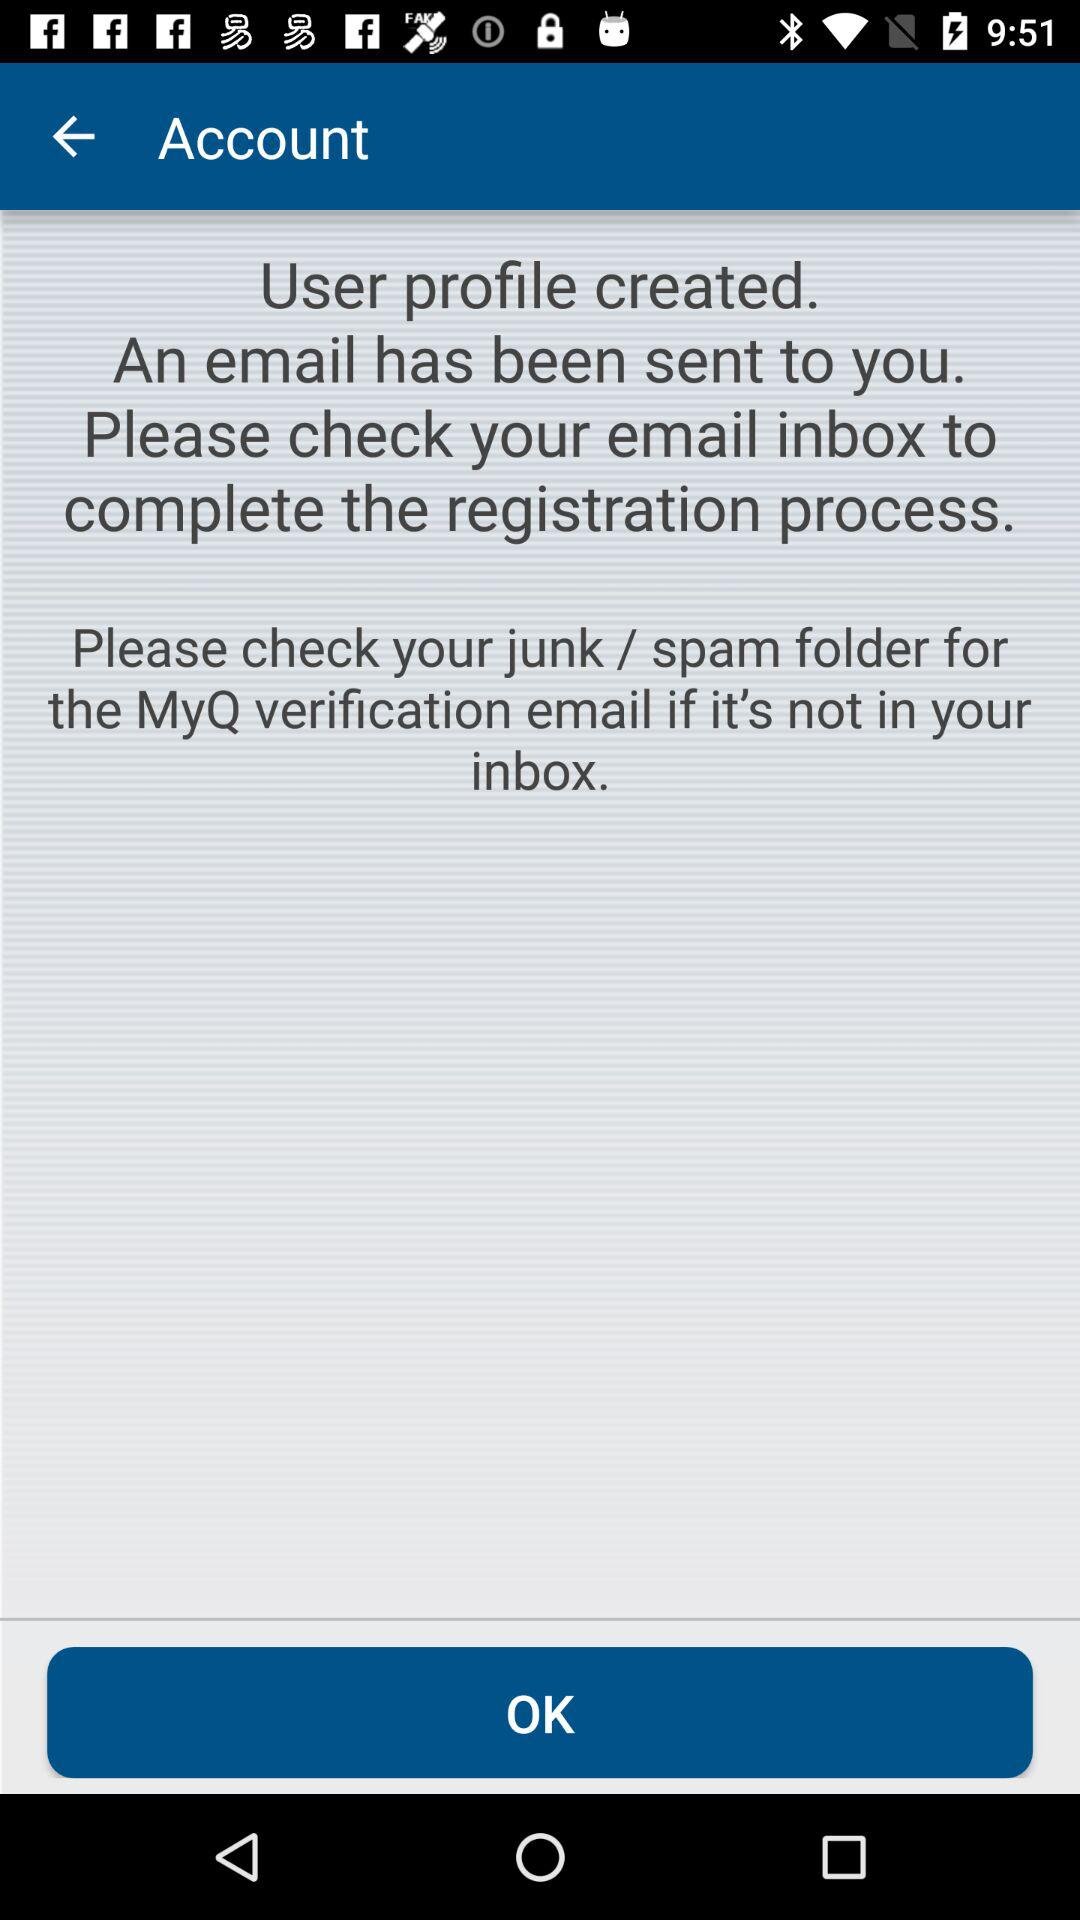How many instructions are given to check the email?
Answer the question using a single word or phrase. 2 